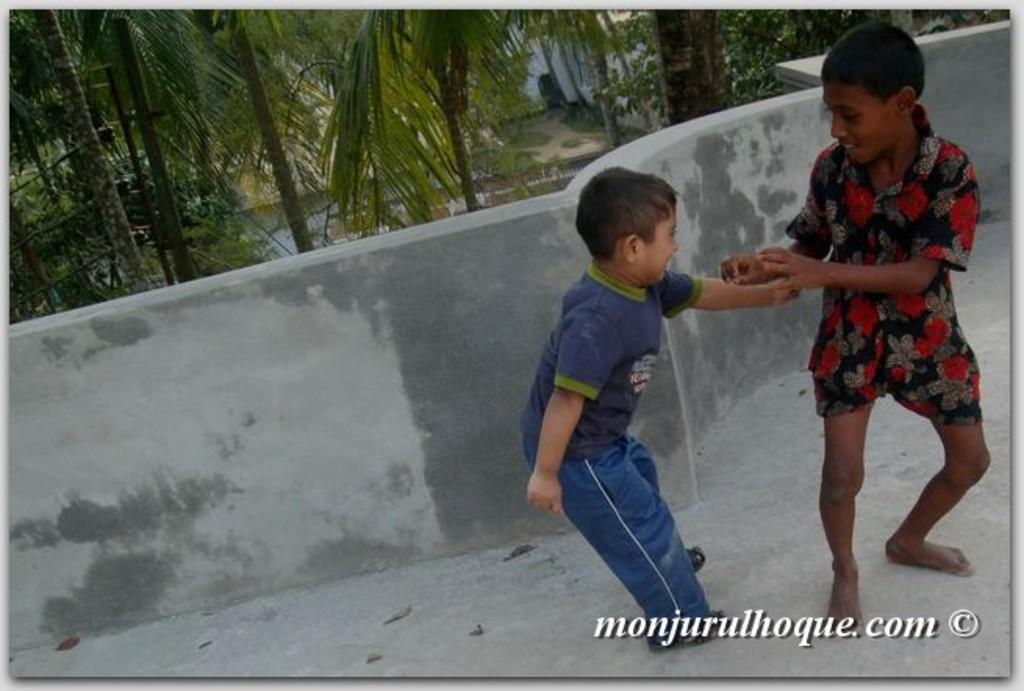What are the two boys in the image doing? The two boys in the image are playing. What type of natural environment is visible in the image? There are trees in the image. What type of structure is visible in the image? There is a house in the image. What architectural feature is visible in the image? There is a wall in the image. What else can be seen in the image besides the boys, trees, house, and wall? There is some text visible on the image. What type of force is being used by the boys to play the game in their minds? There is no mention of a game or the boys' minds in the image, so it is not possible to determine what type of force they might be using. 